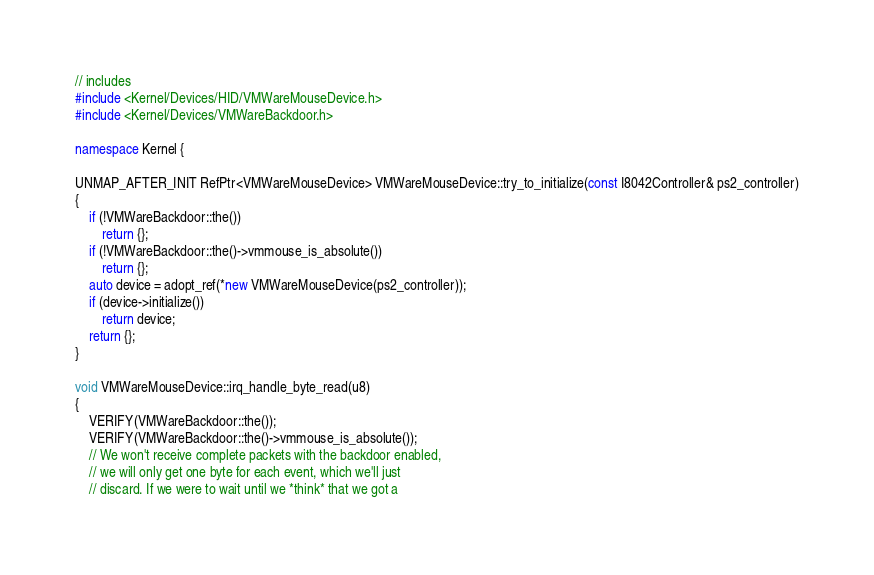Convert code to text. <code><loc_0><loc_0><loc_500><loc_500><_C++_>// includes
#include <Kernel/Devices/HID/VMWareMouseDevice.h>
#include <Kernel/Devices/VMWareBackdoor.h>

namespace Kernel {

UNMAP_AFTER_INIT RefPtr<VMWareMouseDevice> VMWareMouseDevice::try_to_initialize(const I8042Controller& ps2_controller)
{
    if (!VMWareBackdoor::the())
        return {};
    if (!VMWareBackdoor::the()->vmmouse_is_absolute())
        return {};
    auto device = adopt_ref(*new VMWareMouseDevice(ps2_controller));
    if (device->initialize())
        return device;
    return {};
}

void VMWareMouseDevice::irq_handle_byte_read(u8)
{
    VERIFY(VMWareBackdoor::the());
    VERIFY(VMWareBackdoor::the()->vmmouse_is_absolute());
    // We won't receive complete packets with the backdoor enabled,
    // we will only get one byte for each event, which we'll just
    // discard. If we were to wait until we *think* that we got a</code> 